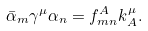Convert formula to latex. <formula><loc_0><loc_0><loc_500><loc_500>\bar { \alpha } _ { m } \gamma ^ { \mu } \alpha _ { n } = f ^ { A } _ { m n } k ^ { \mu } _ { A } .</formula> 